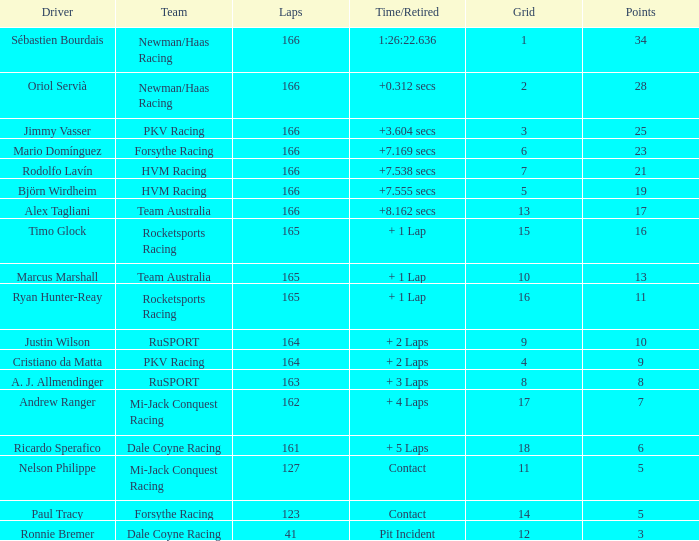What are the typical laps for driver ricardo sperafico? 161.0. I'm looking to parse the entire table for insights. Could you assist me with that? {'header': ['Driver', 'Team', 'Laps', 'Time/Retired', 'Grid', 'Points'], 'rows': [['Sébastien Bourdais', 'Newman/Haas Racing', '166', '1:26:22.636', '1', '34'], ['Oriol Servià', 'Newman/Haas Racing', '166', '+0.312 secs', '2', '28'], ['Jimmy Vasser', 'PKV Racing', '166', '+3.604 secs', '3', '25'], ['Mario Domínguez', 'Forsythe Racing', '166', '+7.169 secs', '6', '23'], ['Rodolfo Lavín', 'HVM Racing', '166', '+7.538 secs', '7', '21'], ['Björn Wirdheim', 'HVM Racing', '166', '+7.555 secs', '5', '19'], ['Alex Tagliani', 'Team Australia', '166', '+8.162 secs', '13', '17'], ['Timo Glock', 'Rocketsports Racing', '165', '+ 1 Lap', '15', '16'], ['Marcus Marshall', 'Team Australia', '165', '+ 1 Lap', '10', '13'], ['Ryan Hunter-Reay', 'Rocketsports Racing', '165', '+ 1 Lap', '16', '11'], ['Justin Wilson', 'RuSPORT', '164', '+ 2 Laps', '9', '10'], ['Cristiano da Matta', 'PKV Racing', '164', '+ 2 Laps', '4', '9'], ['A. J. Allmendinger', 'RuSPORT', '163', '+ 3 Laps', '8', '8'], ['Andrew Ranger', 'Mi-Jack Conquest Racing', '162', '+ 4 Laps', '17', '7'], ['Ricardo Sperafico', 'Dale Coyne Racing', '161', '+ 5 Laps', '18', '6'], ['Nelson Philippe', 'Mi-Jack Conquest Racing', '127', 'Contact', '11', '5'], ['Paul Tracy', 'Forsythe Racing', '123', 'Contact', '14', '5'], ['Ronnie Bremer', 'Dale Coyne Racing', '41', 'Pit Incident', '12', '3']]} 